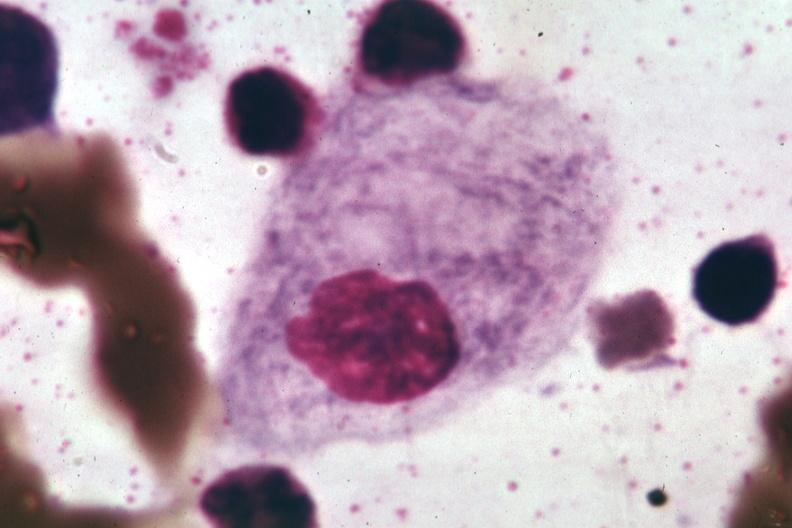what is present?
Answer the question using a single word or phrase. Hematologic 